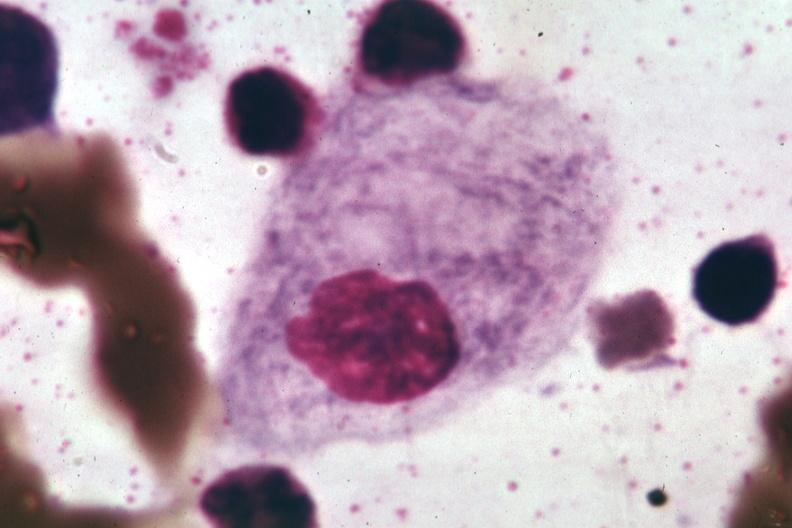what is present?
Answer the question using a single word or phrase. Hematologic 